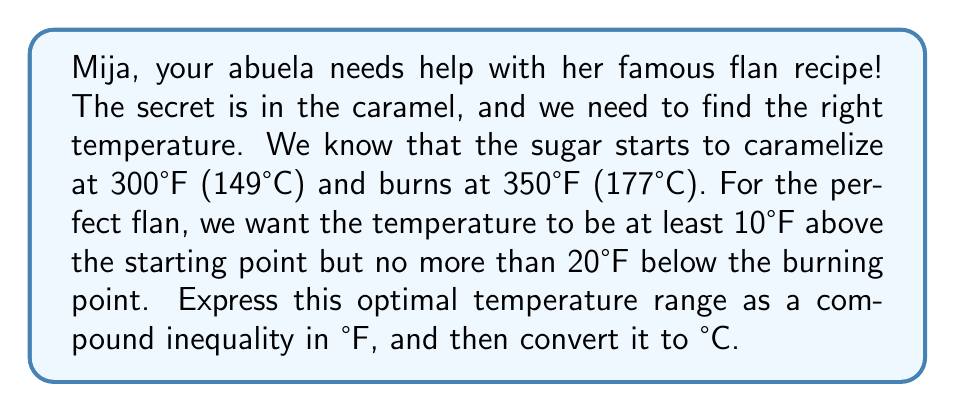Teach me how to tackle this problem. Let's approach this step-by-step, mi amor:

1) First, let's define our variable:
   Let $x$ be the optimal temperature in °F

2) Now, we can express the lower bound:
   $x$ should be at least 10°F above the starting point of 300°F
   $x \geq 300 + 10$
   $x \geq 310$

3) For the upper bound:
   $x$ should be no more than 20°F below the burning point of 350°F
   $x \leq 350 - 20$
   $x \leq 330$

4) Combining these, we get our compound inequality in °F:
   $310 \leq x \leq 330$

5) To convert this to °C, we use the formula: $°C = \frac{5}{9}(°F - 32)$

   For the lower bound: $\frac{5}{9}(310 - 32) = \frac{5}{9}(278) = 154.44°C$
   For the upper bound: $\frac{5}{9}(330 - 32) = \frac{5}{9}(298) = 165.56°C$

6) Rounding to the nearest whole number for practicality in the kitchen:
   $154°C \leq x \leq 166°C$
Answer: The optimal temperature range for caramelizing sugar in °F is:
$$310 \leq x \leq 330$$

The equivalent range in °C is:
$$154 \leq x \leq 166$$ 